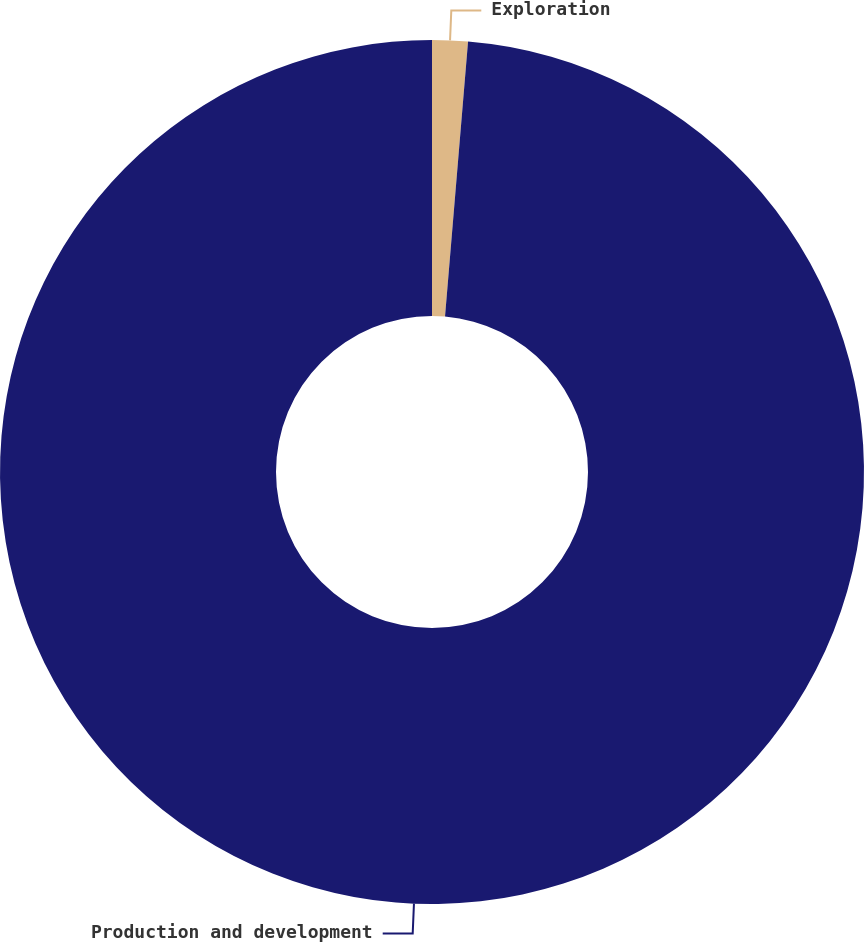Convert chart. <chart><loc_0><loc_0><loc_500><loc_500><pie_chart><fcel>Exploration<fcel>Production and development<nl><fcel>1.33%<fcel>98.67%<nl></chart> 